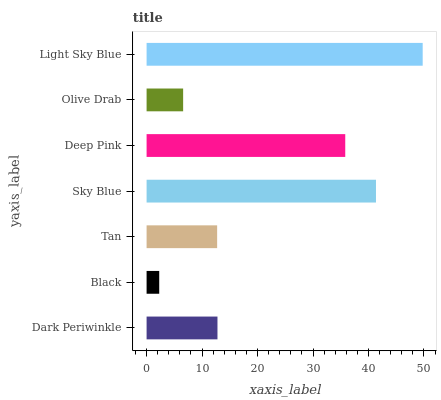Is Black the minimum?
Answer yes or no. Yes. Is Light Sky Blue the maximum?
Answer yes or no. Yes. Is Tan the minimum?
Answer yes or no. No. Is Tan the maximum?
Answer yes or no. No. Is Tan greater than Black?
Answer yes or no. Yes. Is Black less than Tan?
Answer yes or no. Yes. Is Black greater than Tan?
Answer yes or no. No. Is Tan less than Black?
Answer yes or no. No. Is Dark Periwinkle the high median?
Answer yes or no. Yes. Is Dark Periwinkle the low median?
Answer yes or no. Yes. Is Sky Blue the high median?
Answer yes or no. No. Is Light Sky Blue the low median?
Answer yes or no. No. 